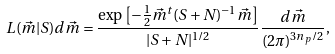Convert formula to latex. <formula><loc_0><loc_0><loc_500><loc_500>L ( \vec { m } | S ) d \vec { m } = \frac { \exp \left [ - \frac { 1 } { 2 } \vec { m } ^ { t } ( S + N ) ^ { - 1 } \vec { m } \right ] } { | S + N | ^ { 1 / 2 } } \frac { d \vec { m } } { ( 2 \pi ) ^ { 3 n _ { p } / 2 } } ,</formula> 